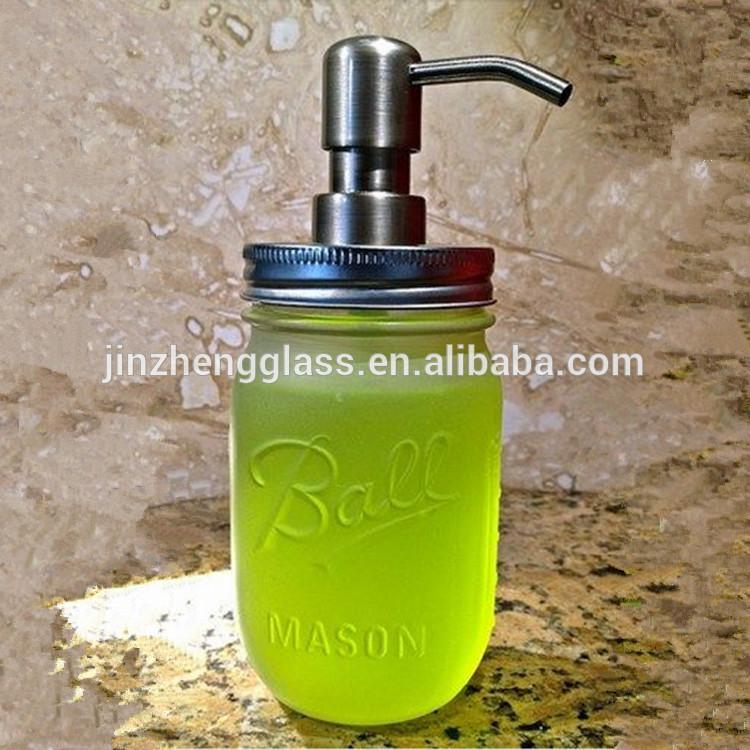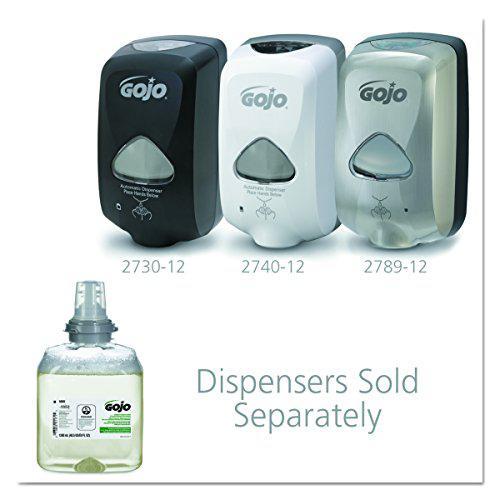The first image is the image on the left, the second image is the image on the right. For the images shown, is this caption "The left and right image contains a total of three wall soap dispensers." true? Answer yes or no. Yes. The first image is the image on the left, the second image is the image on the right. Analyze the images presented: Is the assertion "An image shows a bottle of hand soap on the lower left, and at least two versions of the same style wall-mounted dispenser above it." valid? Answer yes or no. Yes. 